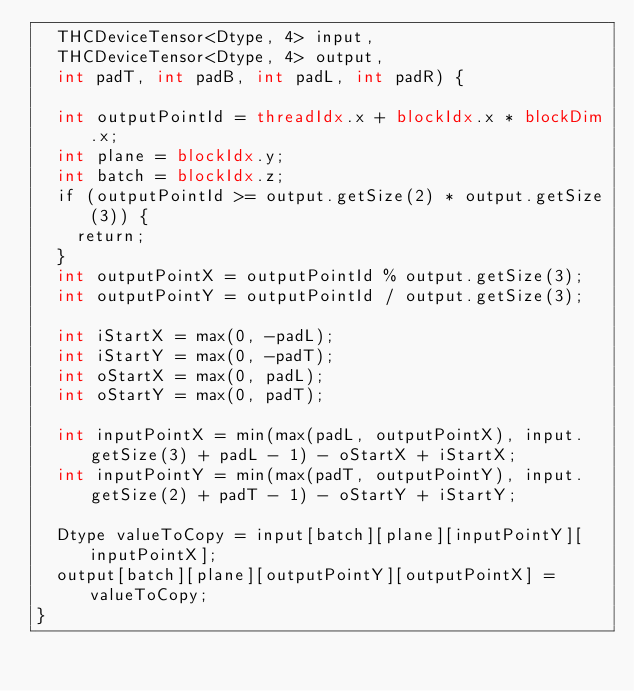<code> <loc_0><loc_0><loc_500><loc_500><_Cuda_>  THCDeviceTensor<Dtype, 4> input,
  THCDeviceTensor<Dtype, 4> output,
  int padT, int padB, int padL, int padR) {

  int outputPointId = threadIdx.x + blockIdx.x * blockDim.x;
  int plane = blockIdx.y;
  int batch = blockIdx.z;
  if (outputPointId >= output.getSize(2) * output.getSize(3)) {
    return;
  }
  int outputPointX = outputPointId % output.getSize(3);
  int outputPointY = outputPointId / output.getSize(3);

  int iStartX = max(0, -padL);
  int iStartY = max(0, -padT);
  int oStartX = max(0, padL);
  int oStartY = max(0, padT);

  int inputPointX = min(max(padL, outputPointX), input.getSize(3) + padL - 1) - oStartX + iStartX;
  int inputPointY = min(max(padT, outputPointY), input.getSize(2) + padT - 1) - oStartY + iStartY;

  Dtype valueToCopy = input[batch][plane][inputPointY][inputPointX];
  output[batch][plane][outputPointY][outputPointX] = valueToCopy;
}
</code> 